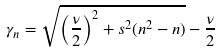Convert formula to latex. <formula><loc_0><loc_0><loc_500><loc_500>\gamma _ { n } = \sqrt { \left ( \frac { \nu } { 2 } \right ) ^ { 2 } + s ^ { 2 } ( n ^ { 2 } - n ) } - \frac { \nu } { 2 }</formula> 